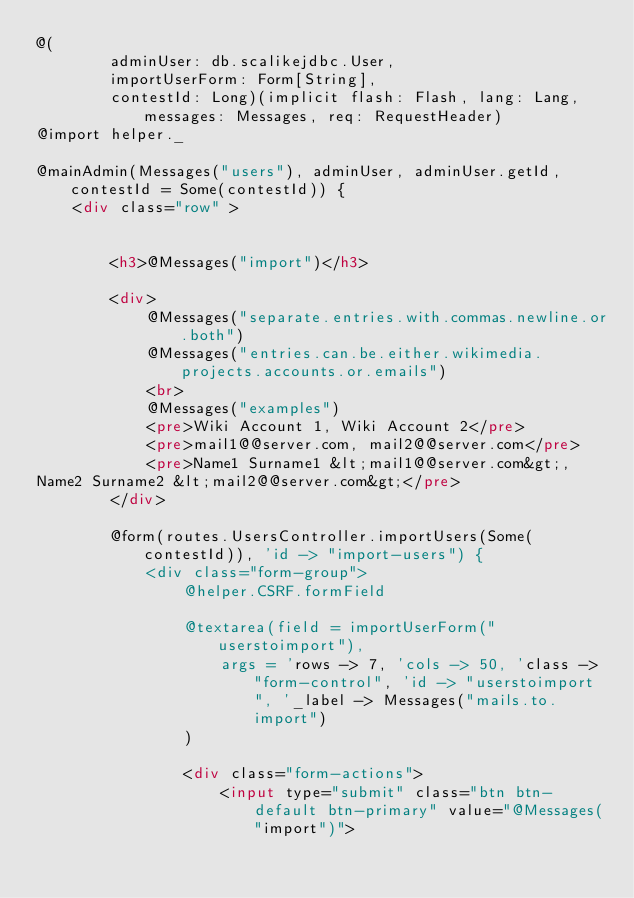Convert code to text. <code><loc_0><loc_0><loc_500><loc_500><_HTML_>@(
        adminUser: db.scalikejdbc.User,
        importUserForm: Form[String],
        contestId: Long)(implicit flash: Flash, lang: Lang, messages: Messages, req: RequestHeader)
@import helper._

@mainAdmin(Messages("users"), adminUser, adminUser.getId, contestId = Some(contestId)) {
    <div class="row" >


        <h3>@Messages("import")</h3>

        <div>
            @Messages("separate.entries.with.commas.newline.or.both")
            @Messages("entries.can.be.either.wikimedia.projects.accounts.or.emails")
            <br>
            @Messages("examples")
            <pre>Wiki Account 1, Wiki Account 2</pre>
            <pre>mail1@@server.com, mail2@@server.com</pre>
            <pre>Name1 Surname1 &lt;mail1@@server.com&gt;,
Name2 Surname2 &lt;mail2@@server.com&gt;</pre>
        </div>

        @form(routes.UsersController.importUsers(Some(contestId)), 'id -> "import-users") {
            <div class="form-group">
                @helper.CSRF.formField

                @textarea(field = importUserForm("userstoimport"),
                    args = 'rows -> 7, 'cols -> 50, 'class -> "form-control", 'id -> "userstoimport", '_label -> Messages("mails.to.import")
                )

                <div class="form-actions">
                    <input type="submit" class="btn btn-default btn-primary" value="@Messages("import")"></code> 